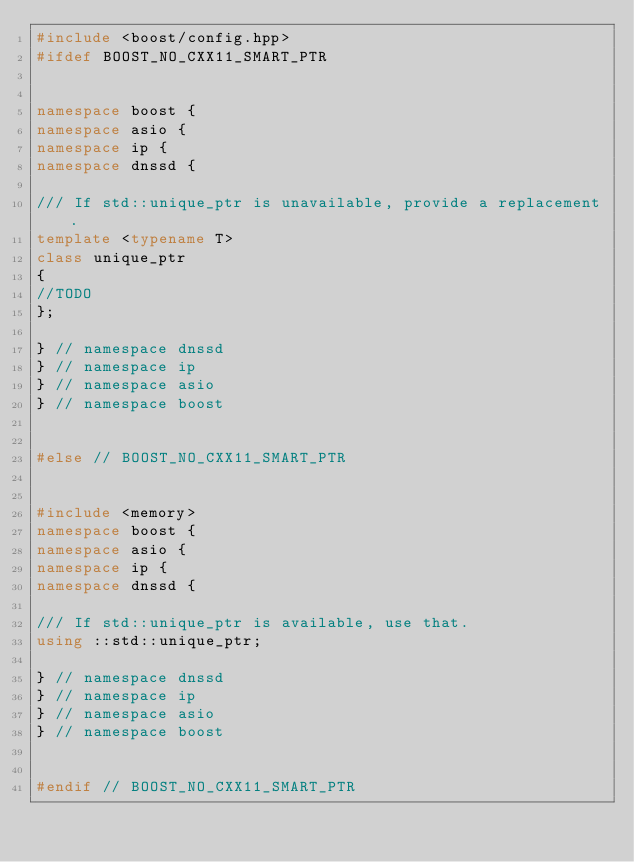Convert code to text. <code><loc_0><loc_0><loc_500><loc_500><_C++_>#include <boost/config.hpp>
#ifdef BOOST_NO_CXX11_SMART_PTR


namespace boost {
namespace asio {
namespace ip {
namespace dnssd {

/// If std::unique_ptr is unavailable, provide a replacement.
template <typename T>
class unique_ptr
{
//TODO
};

} // namespace dnssd
} // namespace ip
} // namespace asio
} // namespace boost


#else // BOOST_NO_CXX11_SMART_PTR


#include <memory>
namespace boost {
namespace asio {
namespace ip {
namespace dnssd {

/// If std::unique_ptr is available, use that.
using ::std::unique_ptr;

} // namespace dnssd
} // namespace ip
} // namespace asio
} // namespace boost


#endif // BOOST_NO_CXX11_SMART_PTR
</code> 